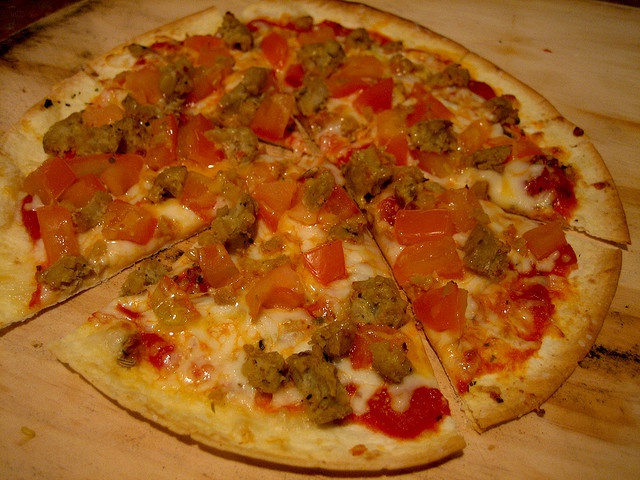Describe the objects in this image and their specific colors. I can see pizza in black, brown, maroon, and tan tones, pizza in black, red, maroon, tan, and orange tones, and pizza in black, brown, maroon, and orange tones in this image. 